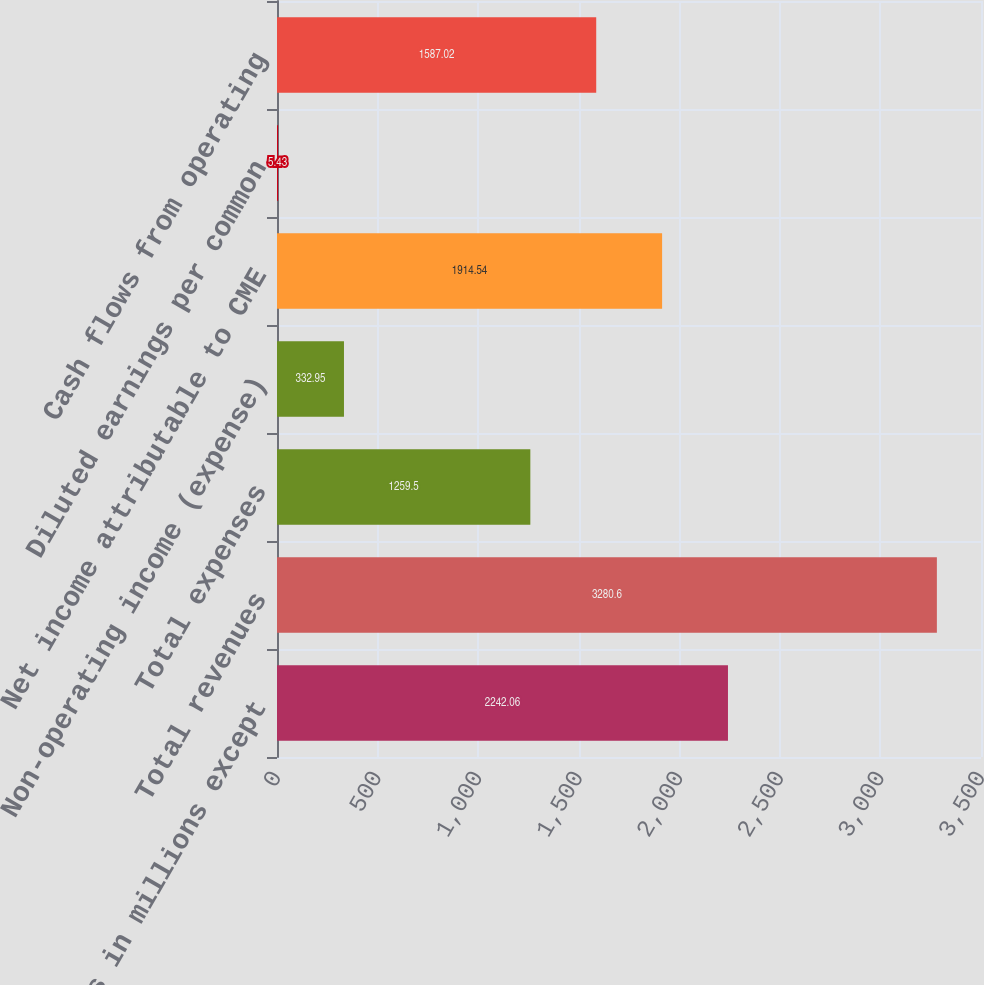Convert chart to OTSL. <chart><loc_0><loc_0><loc_500><loc_500><bar_chart><fcel>(dollars in millions except<fcel>Total revenues<fcel>Total expenses<fcel>Non-operating income (expense)<fcel>Net income attributable to CME<fcel>Diluted earnings per common<fcel>Cash flows from operating<nl><fcel>2242.06<fcel>3280.6<fcel>1259.5<fcel>332.95<fcel>1914.54<fcel>5.43<fcel>1587.02<nl></chart> 